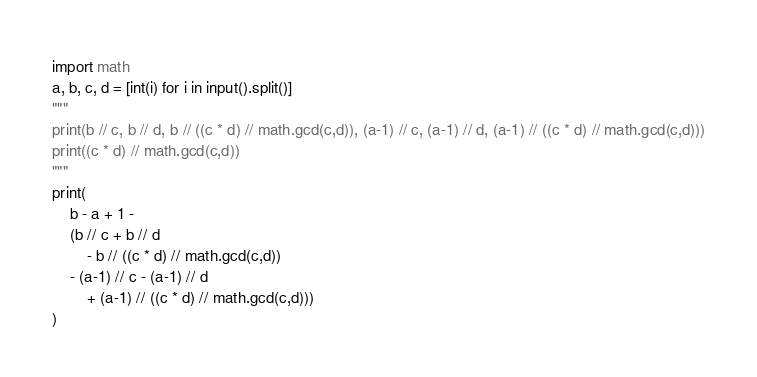<code> <loc_0><loc_0><loc_500><loc_500><_Python_>import math
a, b, c, d = [int(i) for i in input().split()]
"""
print(b // c, b // d, b // ((c * d) // math.gcd(c,d)), (a-1) // c, (a-1) // d, (a-1) // ((c * d) // math.gcd(c,d)))
print((c * d) // math.gcd(c,d))
"""
print(
    b - a + 1 - 
    (b // c + b // d 
        - b // ((c * d) // math.gcd(c,d)) 
    - (a-1) // c - (a-1) // d 
        + (a-1) // ((c * d) // math.gcd(c,d)))
)
</code> 